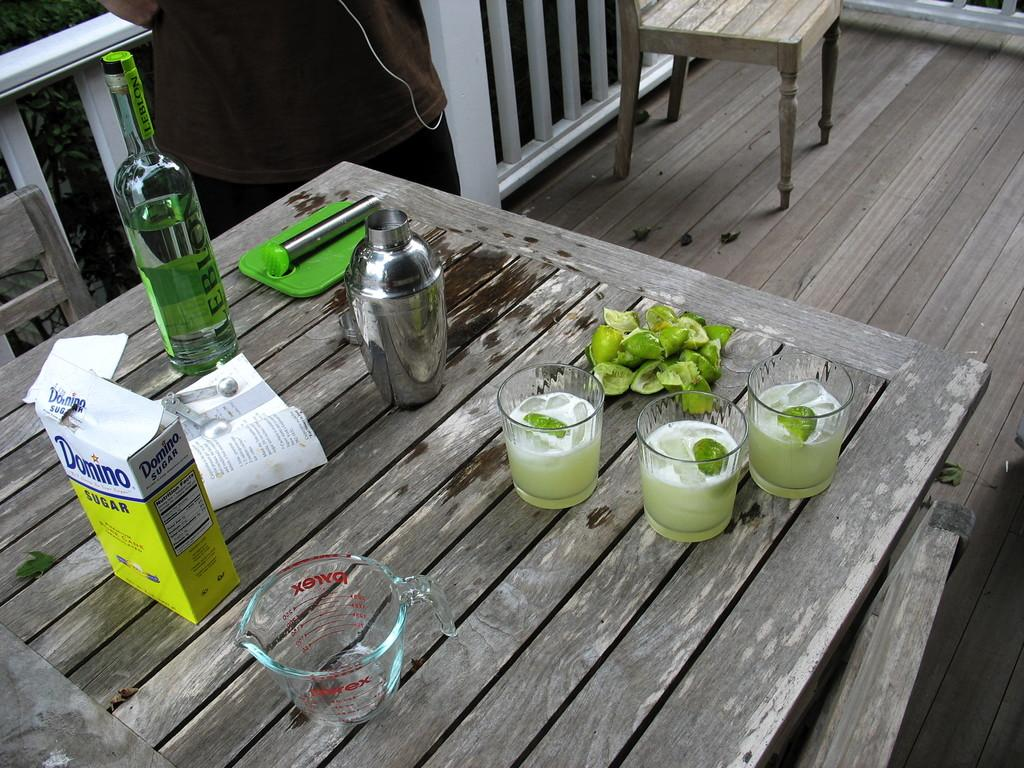What type of objects are on the table in the image? There are glasses, a jug, and a bottle on the table in the image. What might be the purpose of the jug and bottle on the table? The jug and bottle on the table might contain a beverage, such as water or juice. How many objects are on the table in the image? There are three objects on the table: glasses, a jug, and a bottle. Can you hear the table laughing in the image? There is no indication of laughter or sound in the image, as it is a still image. 